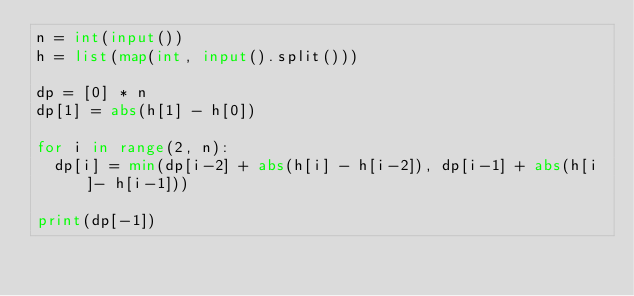Convert code to text. <code><loc_0><loc_0><loc_500><loc_500><_Python_>n = int(input())
h = list(map(int, input().split()))

dp = [0] * n
dp[1] = abs(h[1] - h[0])

for i in range(2, n):
  dp[i] = min(dp[i-2] + abs(h[i] - h[i-2]), dp[i-1] + abs(h[i]- h[i-1]))

print(dp[-1])</code> 